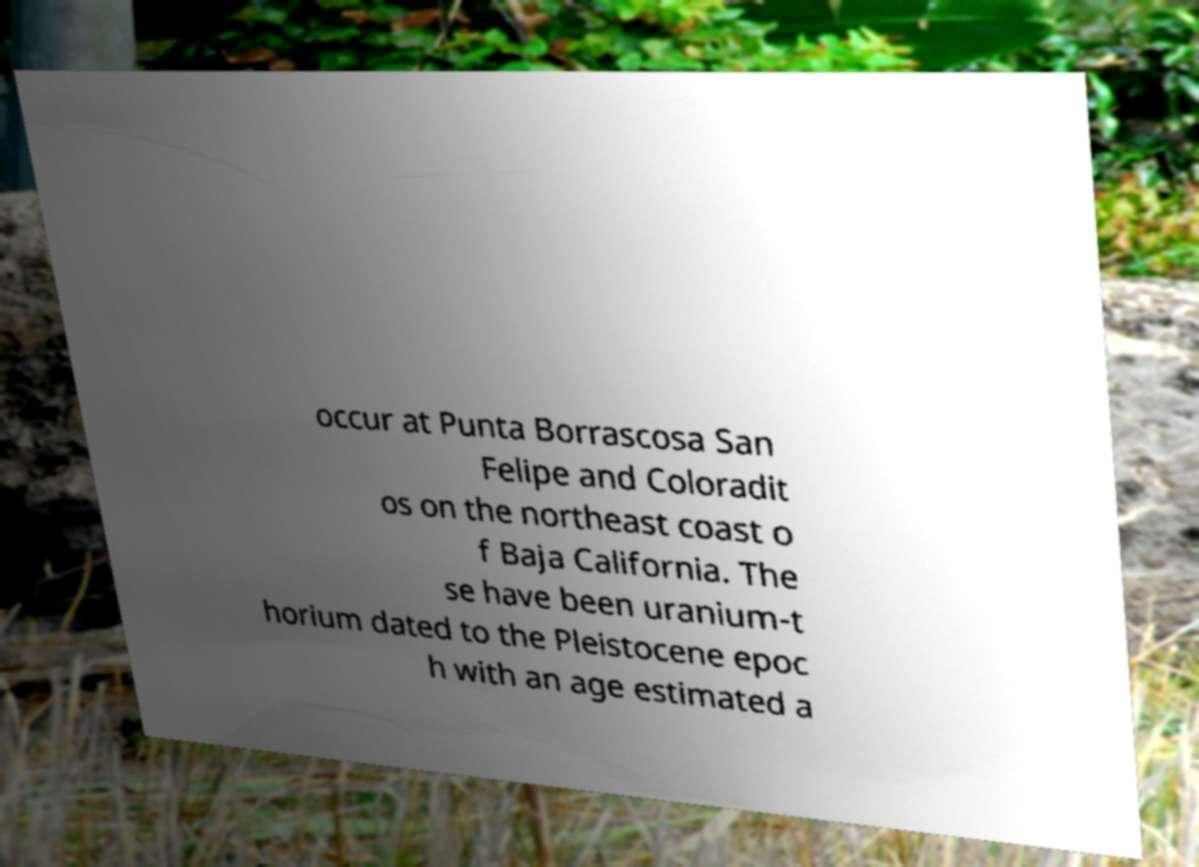Please identify and transcribe the text found in this image. occur at Punta Borrascosa San Felipe and Coloradit os on the northeast coast o f Baja California. The se have been uranium-t horium dated to the Pleistocene epoc h with an age estimated a 